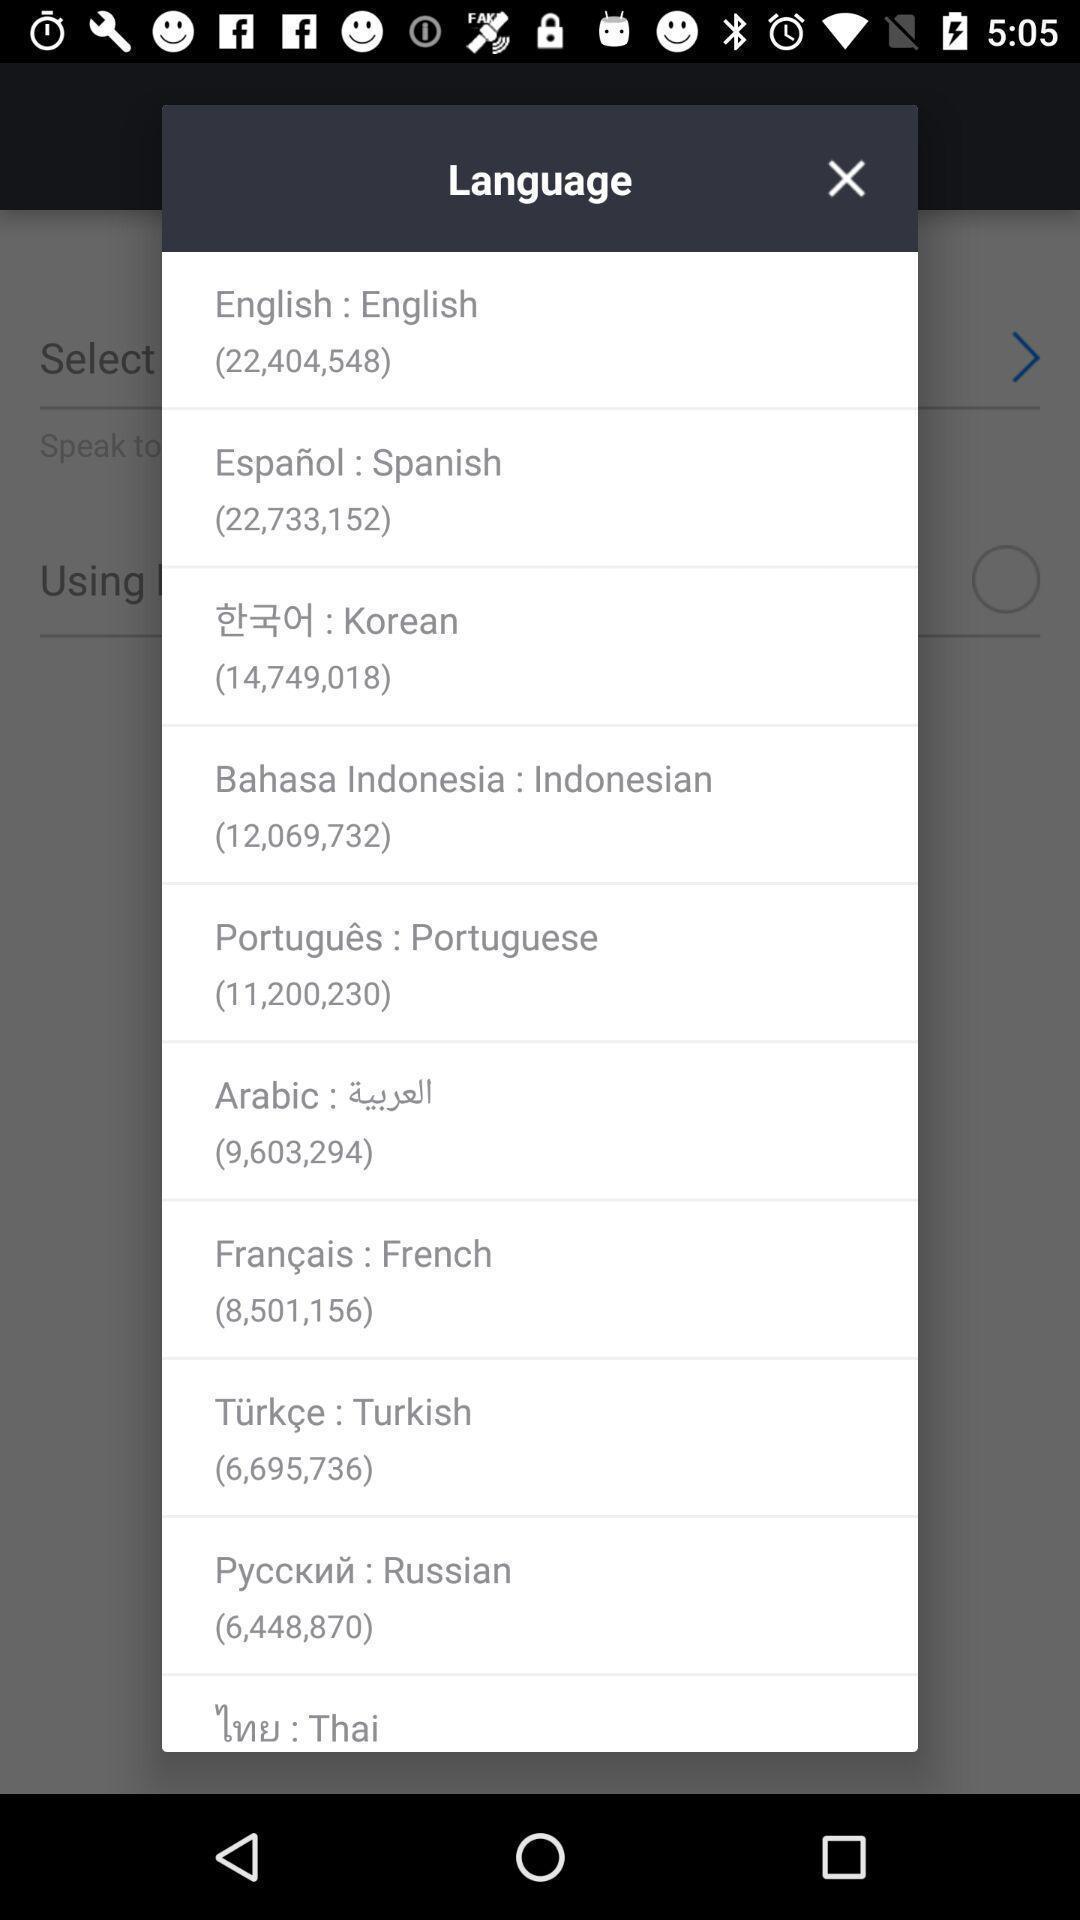Provide a detailed account of this screenshot. Pop-up showing to select language. 